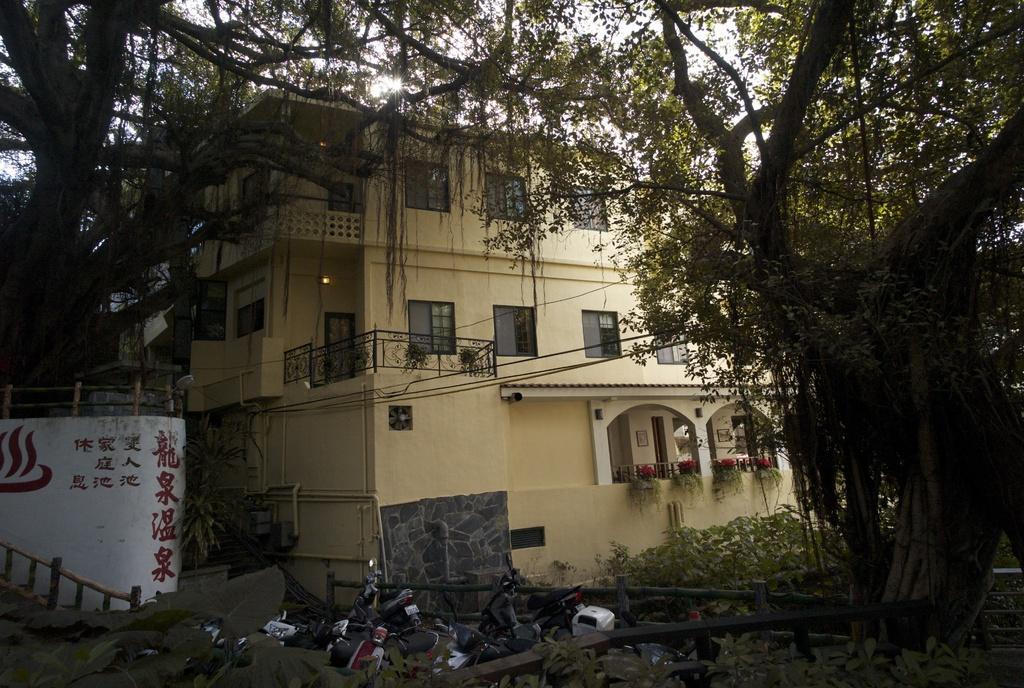In one or two sentences, can you explain what this image depicts? In this picture I can see a building, there are lights, plants, there are vehicles, there are trees, and in the background there is sky. 